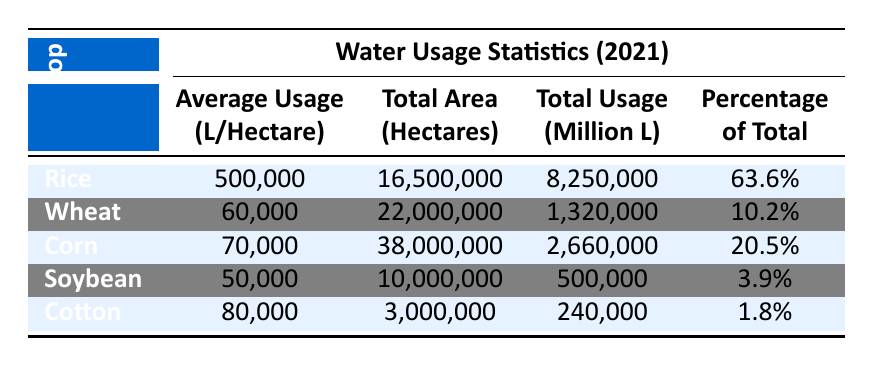What is the total water usage for Rice? The total water usage for Rice is provided in the Total Usage column for the Rice row, which shows 8,250,000 million liters.
Answer: 8,250,000 million liters Which crop has the highest average water usage per hectare? By comparing the Average Usage column, Rice has the highest value at 500,000 liters per hectare compared to Wheat (60,000), Corn (70,000), Soybean (50,000), and Cotton (80,000).
Answer: Rice What is the total combined water usage for Wheat and Corn? To find the total combined water usage, we add the Total Usage for Wheat (1,320,000 million liters) and Corn (2,660,000 million liters) together: 1,320,000 + 2,660,000 = 3,980,000 million liters.
Answer: 3,980,000 million liters Is the total area planted for Soybean greater than that for Cotton? Looking at the Total Area column, Soybean has 10,000,000 hectares while Cotton has 3,000,000 hectares. Since 10,000,000 is greater than 3,000,000, the statement is true.
Answer: Yes What percentage of total water usage does Corn represent? The percentage of total water usage for Corn is given directly in the table, showing it as 20.5%.
Answer: 20.5% Calculate the average water usage per hectare among all crops listed. To find the average, we sum the Average Usage values for all crops (500,000 + 60,000 + 70,000 + 50,000 + 80,000 = 760,000) and divide by the number of crops (5). So the average is 760,000 / 5 = 152,000 liters per hectare.
Answer: 152,000 liters per hectare Which crop is responsible for only 1.8% of total water usage? In the table, Cotton is listed with a percentage of 1.8% in the Percentage column, indicating its low contribution relative to total water usage.
Answer: Cotton How much water is used for Cotton compared to Wheat? Cotton uses 240,000 million liters while Wheat uses 1,320,000 million liters. To compare, Wheat uses significantly more water; 1,320,000 is much greater than 240,000.
Answer: Wheat uses more water 